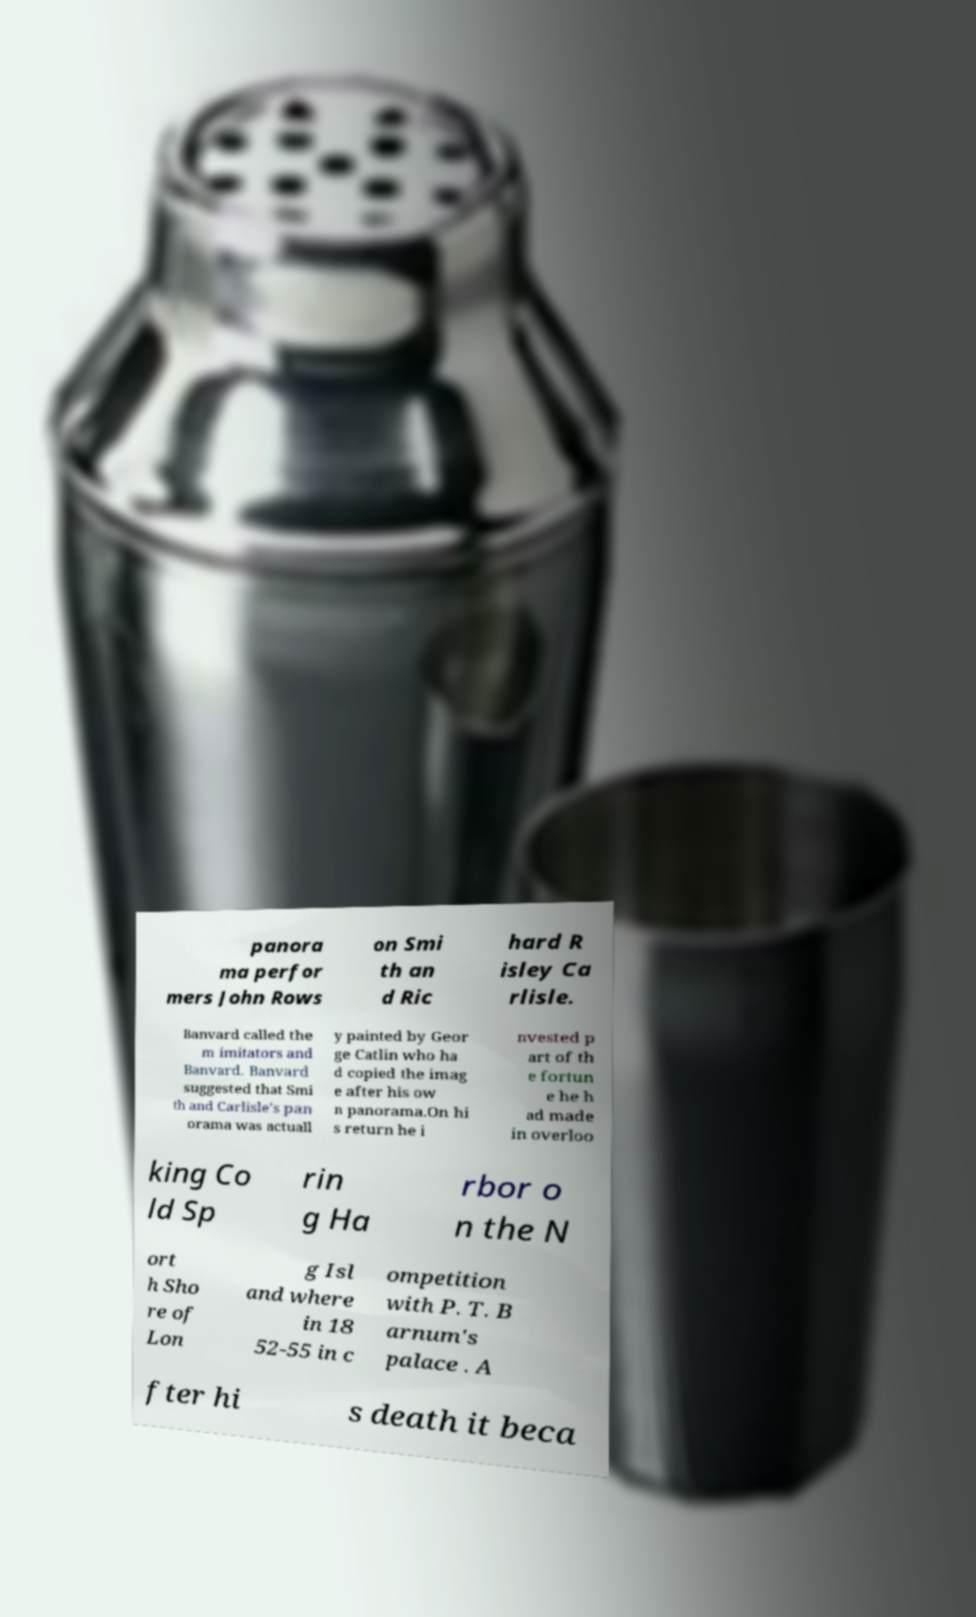Please identify and transcribe the text found in this image. panora ma perfor mers John Rows on Smi th an d Ric hard R isley Ca rlisle. Banvard called the m imitators and Banvard. Banvard suggested that Smi th and Carlisle's pan orama was actuall y painted by Geor ge Catlin who ha d copied the imag e after his ow n panorama.On hi s return he i nvested p art of th e fortun e he h ad made in overloo king Co ld Sp rin g Ha rbor o n the N ort h Sho re of Lon g Isl and where in 18 52-55 in c ompetition with P. T. B arnum's palace . A fter hi s death it beca 